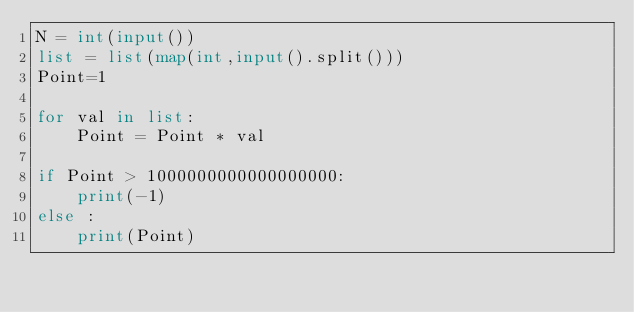Convert code to text. <code><loc_0><loc_0><loc_500><loc_500><_Python_>N = int(input())
list = list(map(int,input().split()))
Point=1

for val in list:
    Point = Point * val

if Point > 1000000000000000000:
    print(-1)
else :
    print(Point)
</code> 